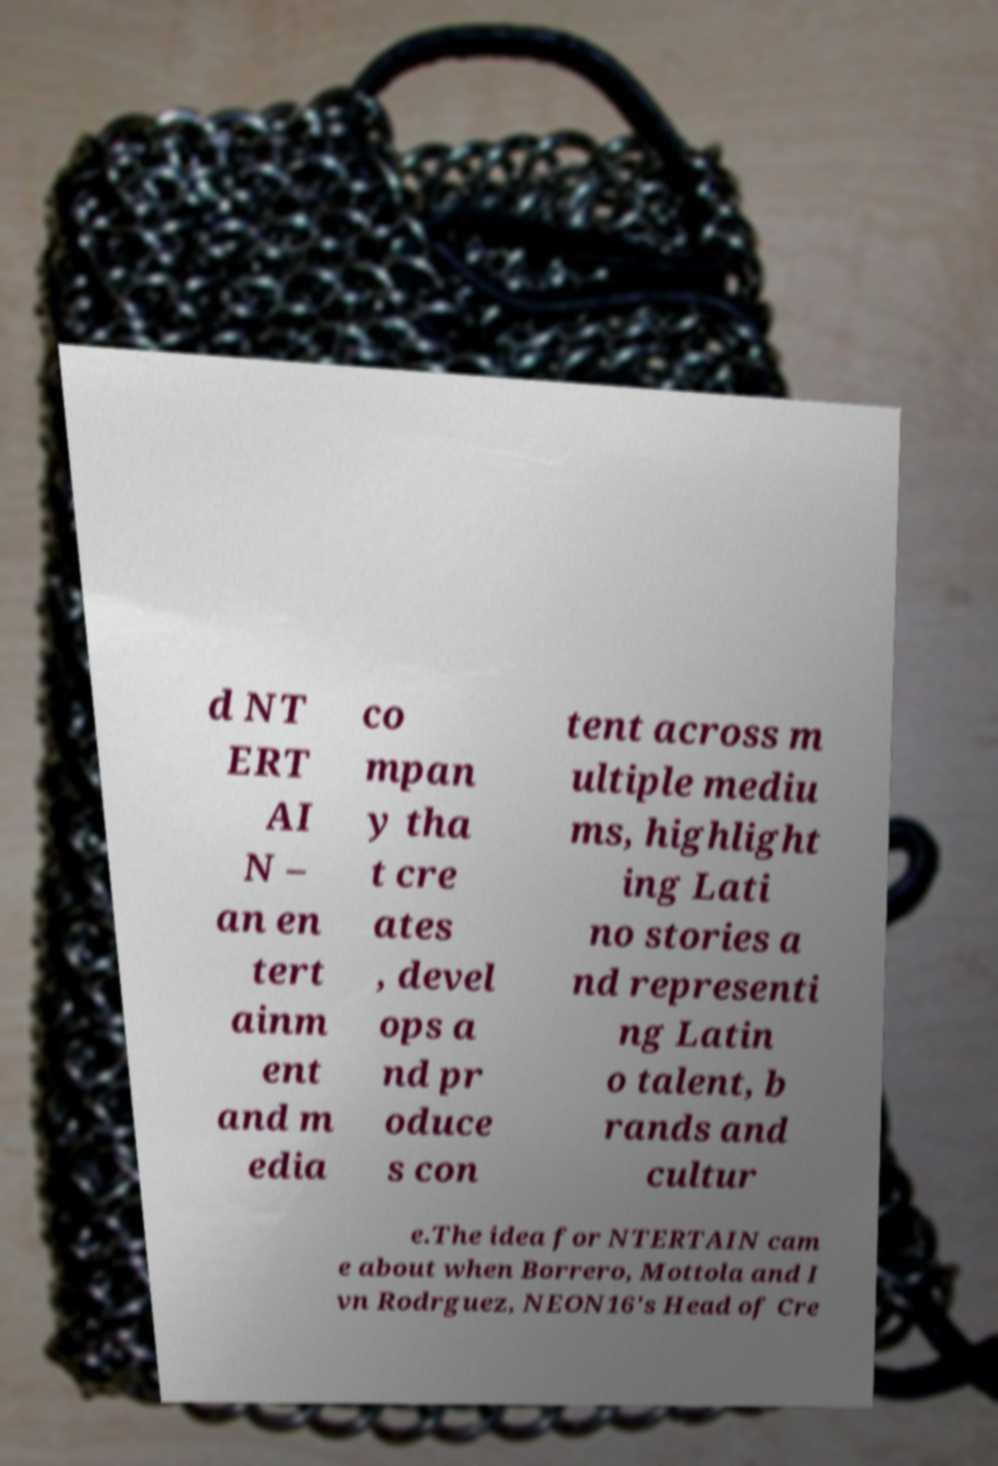What messages or text are displayed in this image? I need them in a readable, typed format. d NT ERT AI N – an en tert ainm ent and m edia co mpan y tha t cre ates , devel ops a nd pr oduce s con tent across m ultiple mediu ms, highlight ing Lati no stories a nd representi ng Latin o talent, b rands and cultur e.The idea for NTERTAIN cam e about when Borrero, Mottola and I vn Rodrguez, NEON16's Head of Cre 